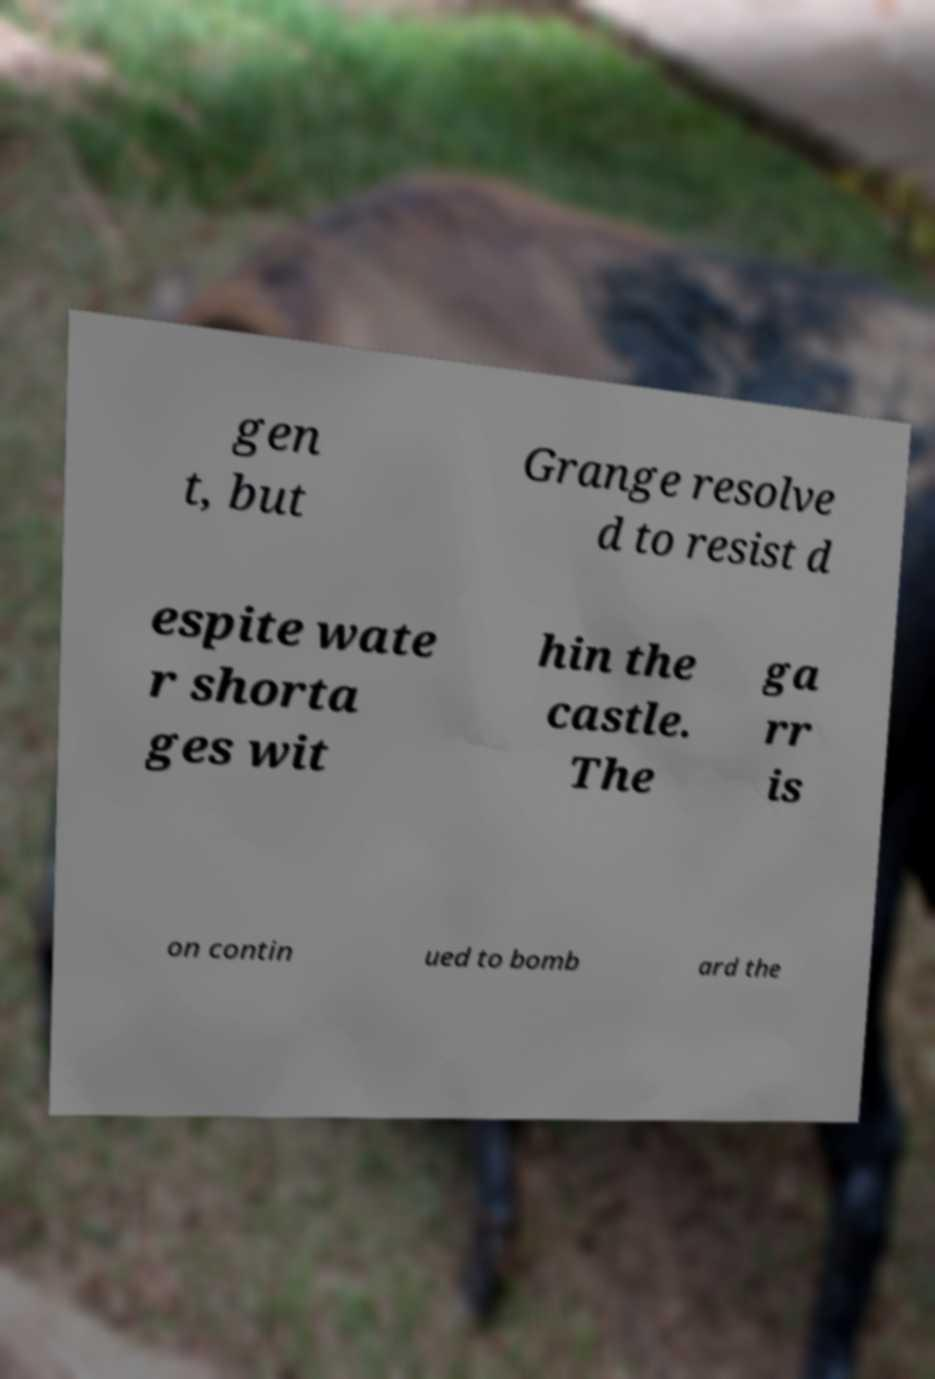For documentation purposes, I need the text within this image transcribed. Could you provide that? gen t, but Grange resolve d to resist d espite wate r shorta ges wit hin the castle. The ga rr is on contin ued to bomb ard the 